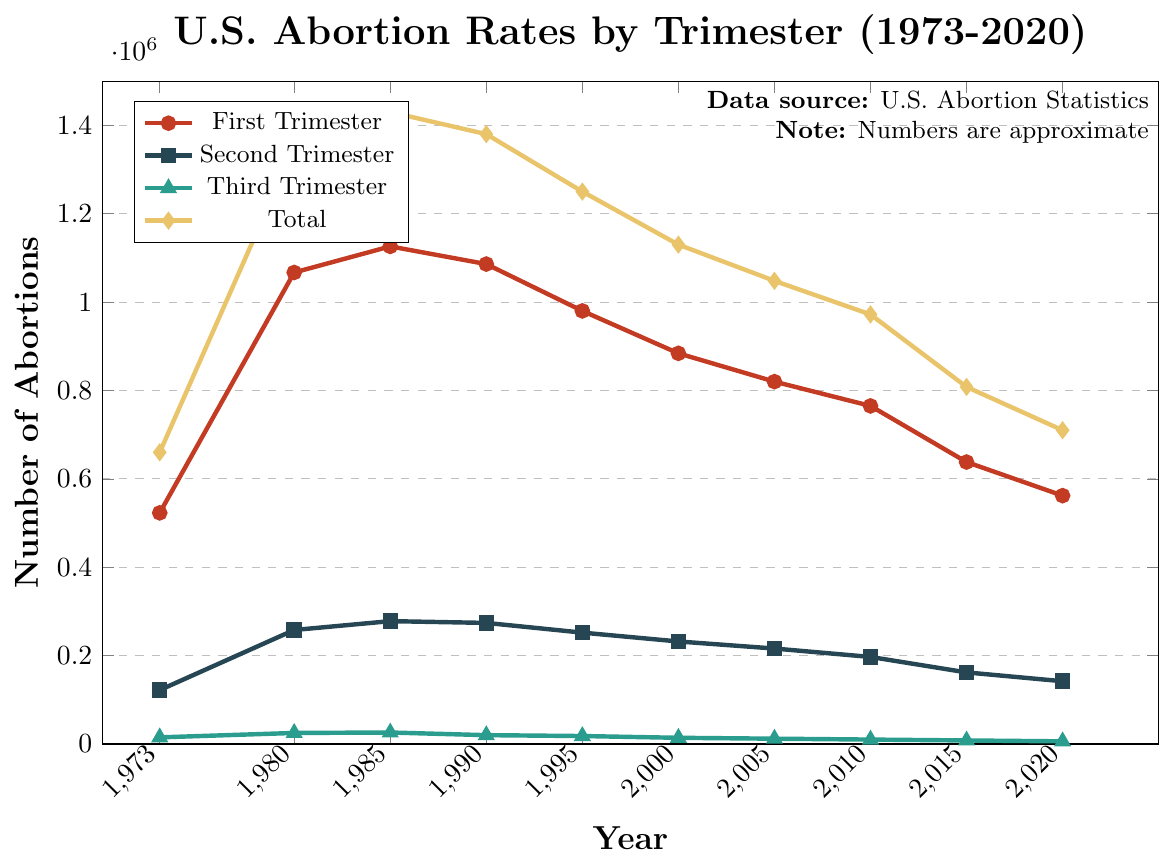What year had the highest total number of abortions? The orange diamond markers represent the total number of abortions. The highest point is at the year 1985 with 1,430,000 abortions.
Answer: 1985 Which trimester consistently had the lowest number of abortions across the years? The green triangle markers represent third-trimester abortions, and they consistently have the lowest values in comparison to the first and second trimesters.
Answer: Third Trimester How much did the total number of abortions decrease from 1980 to 2020? In 1980, the total was 1,350,000, and in 2020, it was 710,000. The difference is 1,350,000 - 710,000.
Answer: 640,000 What was the average number of first-trimester abortions in 1985 and 1990? The number of first-trimester abortions in 1985 was 1,126,000, and in 1990 it was 1,086,000. The average is (1,126,000 + 1,086,000) / 2.
Answer: 1,106,000 Which year saw the highest number of second-trimester abortions, and what was that number? The blue square markers represent second-trimester abortions. The highest point is at 1985 with 278,000 abortions.
Answer: 1985, 278,000 How did the number of third-trimester abortions change from 1973 to 2020? In 1973, there were 15,000 third-trimester abortions, and in 2020, there were 6,000. The change is 15,000 - 6,000.
Answer: Decreased by 9,000 What was the total number of abortions in 2015, and how does it compare to the total in 2020? In 2015, the total number was 808,000, and in 2020 it was 710,000. Compare these two numbers to see if it increased or decreased.
Answer: Decreased by 98,000 Which trimester had the greatest absolute decrease in the number of abortions from 1973 to 2020? For each trimester, calculate the absolute decrease from 1973 to 2020. First: 523,000 - 562,000 = -39,000 (increase), Second: 122,000 - 142,000 = -20,000 (increase), Third: 15,000 - 6,000 = 9,000 (decrease). The third trimester had the greatest absolute decrease.
Answer: Third Trimester What is the trend in the total number of abortions from 1990 to 2020? Observing the orange diamond markers from 1990 (1,380,000) to 2020 (710,000) shows a consistent downward trend.
Answer: Downward In which year do first-trimester abortions start to significantly decline from their peak? First-trimester abortions peak in 1985 with 1,126,000, and by 1990 it starts to significantly decline.
Answer: 1985 to 1990 